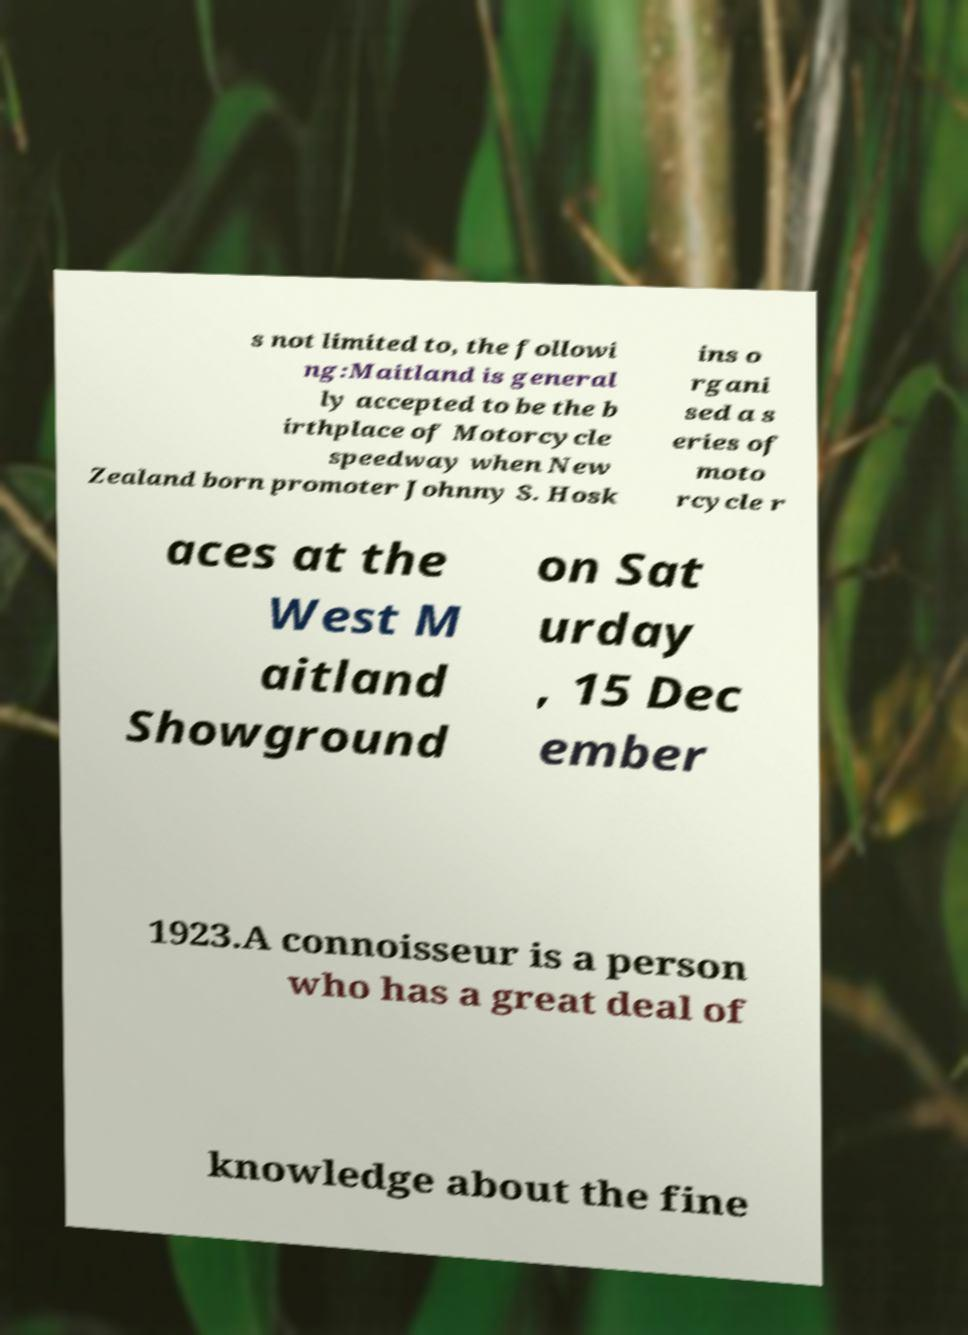Can you accurately transcribe the text from the provided image for me? s not limited to, the followi ng:Maitland is general ly accepted to be the b irthplace of Motorcycle speedway when New Zealand born promoter Johnny S. Hosk ins o rgani sed a s eries of moto rcycle r aces at the West M aitland Showground on Sat urday , 15 Dec ember 1923.A connoisseur is a person who has a great deal of knowledge about the fine 